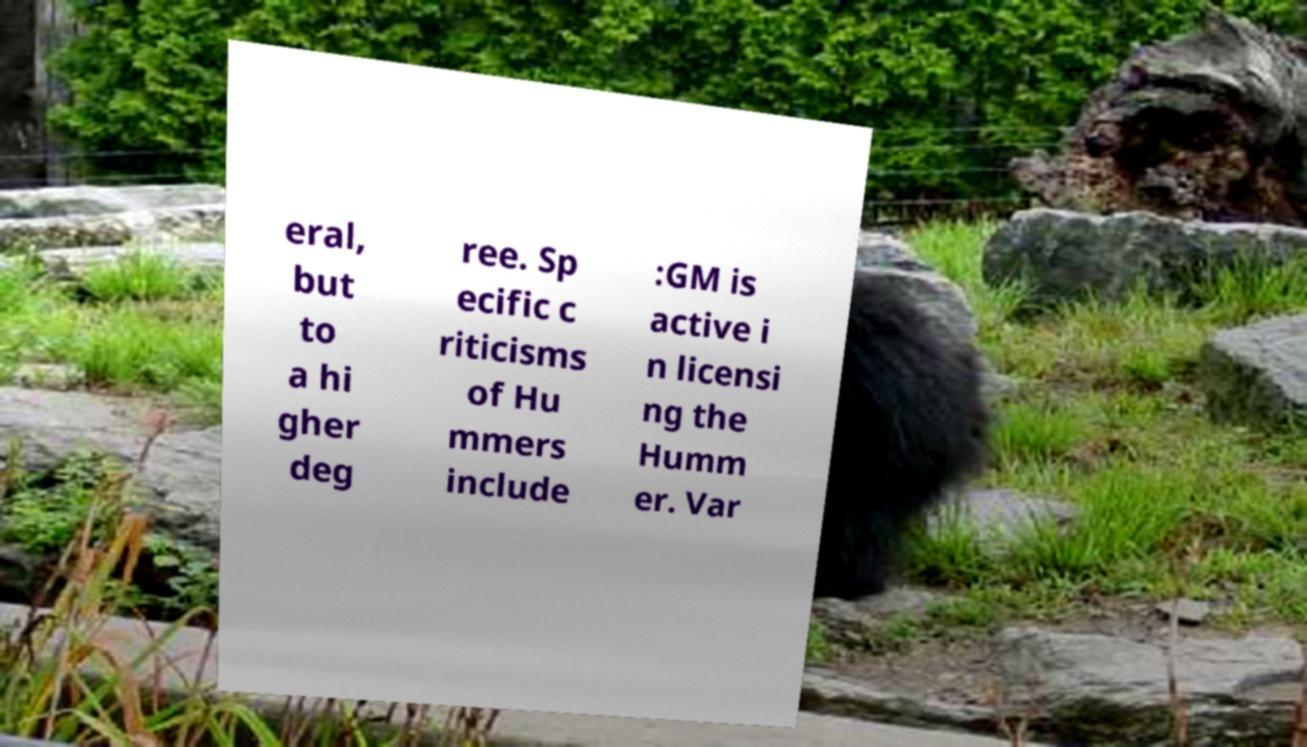Can you accurately transcribe the text from the provided image for me? eral, but to a hi gher deg ree. Sp ecific c riticisms of Hu mmers include :GM is active i n licensi ng the Humm er. Var 